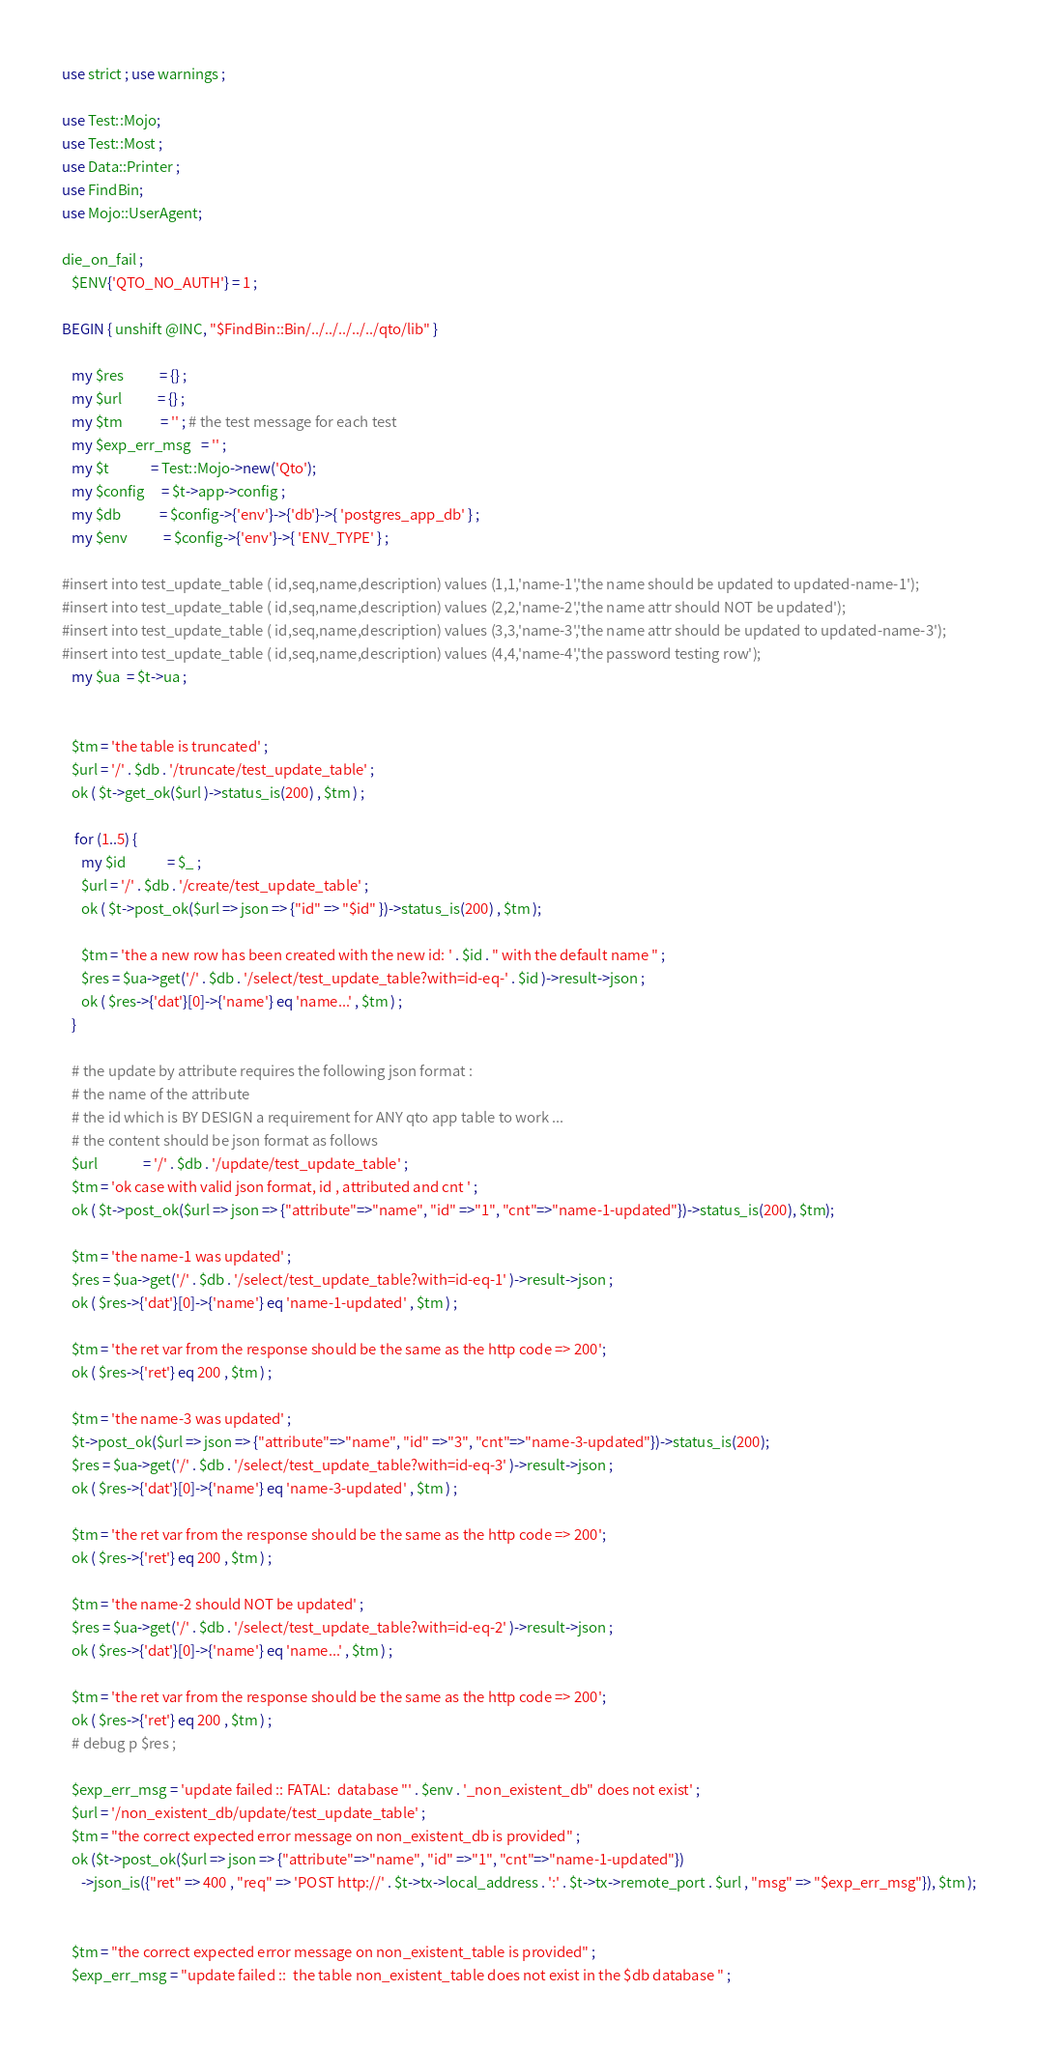Convert code to text. <code><loc_0><loc_0><loc_500><loc_500><_Perl_>use strict ; use warnings ; 

use Test::Mojo;
use Test::Most ; 
use Data::Printer ; 
use FindBin;
use Mojo::UserAgent;

die_on_fail ; 
   $ENV{'QTO_NO_AUTH'} = 1 ;

BEGIN { unshift @INC, "$FindBin::Bin/../../../../../qto/lib" }

   my $res           = {} ; 
   my $url           = {} ; 
   my $tm            = '' ; # the test message for each test 
   my $exp_err_msg   = '' ; 
   my $t             = Test::Mojo->new('Qto');
   my $config     = $t->app->config ; 
   my $db            = $config->{'env'}->{'db'}->{ 'postgres_app_db' } ; 
   my $env           = $config->{'env'}->{ 'ENV_TYPE' } ;

#insert into test_update_table ( id,seq,name,description) values (1,1,'name-1','the name should be updated to updated-name-1'); 
#insert into test_update_table ( id,seq,name,description) values (2,2,'name-2','the name attr should NOT be updated'); 
#insert into test_update_table ( id,seq,name,description) values (3,3,'name-3','the name attr should be updated to updated-name-3'); 
#insert into test_update_table ( id,seq,name,description) values (4,4,'name-4','the password testing row'); 
   my $ua  = $t->ua ; 


   $tm = 'the table is truncated' ; 
   $url = '/' . $db . '/truncate/test_update_table' ; 
   ok ( $t->get_ok($url )->status_is(200) , $tm ) ;

	for (1..5) { 
      my $id             = $_ ;
      $url = '/' . $db . '/create/test_update_table' ; 
      ok ( $t->post_ok($url => json => {"id" => "$id" })->status_is(200) , $tm );

      $tm = 'the a new row has been created with the new id: ' . $id . " with the default name " ; 
      $res = $ua->get('/' . $db . '/select/test_update_table?with=id-eq-' . $id )->result->json ; 
      ok ( $res->{'dat'}[0]->{'name'} eq 'name...' , $tm ) ; 
   }

   # the update by attribute requires the following json format : 
   # the name of the attribute
   # the id which is BY DESIGN a requirement for ANY qto app table to work ... 
   # the content should be json format as follows
   $url              = '/' . $db . '/update/test_update_table' ; 
   $tm = 'ok case with valid json format, id , attributed and cnt ' ; 
   ok ( $t->post_ok($url => json => {"attribute"=>"name", "id" =>"1", "cnt"=>"name-1-updated"})->status_is(200), $tm);

   $tm = 'the name-1 was updated' ; 
   $res = $ua->get('/' . $db . '/select/test_update_table?with=id-eq-1' )->result->json ; 
   ok ( $res->{'dat'}[0]->{'name'} eq 'name-1-updated' , $tm ) ; 
   
   $tm = 'the ret var from the response should be the same as the http code => 200'; 
   ok ( $res->{'ret'} eq 200 , $tm ) ; 
  
   $tm = 'the name-3 was updated' ; 
   $t->post_ok($url => json => {"attribute"=>"name", "id" =>"3", "cnt"=>"name-3-updated"})->status_is(200);
   $res = $ua->get('/' . $db . '/select/test_update_table?with=id-eq-3' )->result->json ; 
   ok ( $res->{'dat'}[0]->{'name'} eq 'name-3-updated' , $tm ) ; 
   
   $tm = 'the ret var from the response should be the same as the http code => 200'; 
   ok ( $res->{'ret'} eq 200 , $tm ) ; 
   
   $tm = 'the name-2 should NOT be updated' ; 
   $res = $ua->get('/' . $db . '/select/test_update_table?with=id-eq-2' )->result->json ; 
   ok ( $res->{'dat'}[0]->{'name'} eq 'name...' , $tm ) ; 
   
   $tm = 'the ret var from the response should be the same as the http code => 200'; 
   ok ( $res->{'ret'} eq 200 , $tm ) ; 
   # debug p $res ; 

   $exp_err_msg = 'update failed :: FATAL:  database "' . $env . '_non_existent_db" does not exist' ;
   $url = '/non_existent_db/update/test_update_table' ; 
   $tm = "the correct expected error message on non_existent_db is provided" ; 
   ok ($t->post_ok($url => json => {"attribute"=>"name", "id" =>"1", "cnt"=>"name-1-updated"})
      ->json_is({"ret" => 400 , "req" => 'POST http://' . $t->tx->local_address . ':' . $t->tx->remote_port . $url , "msg" => "$exp_err_msg"}), $tm );

  
   $tm = "the correct expected error message on non_existent_table is provided" ; 
   $exp_err_msg = "update failed ::  the table non_existent_table does not exist in the $db database " ; </code> 